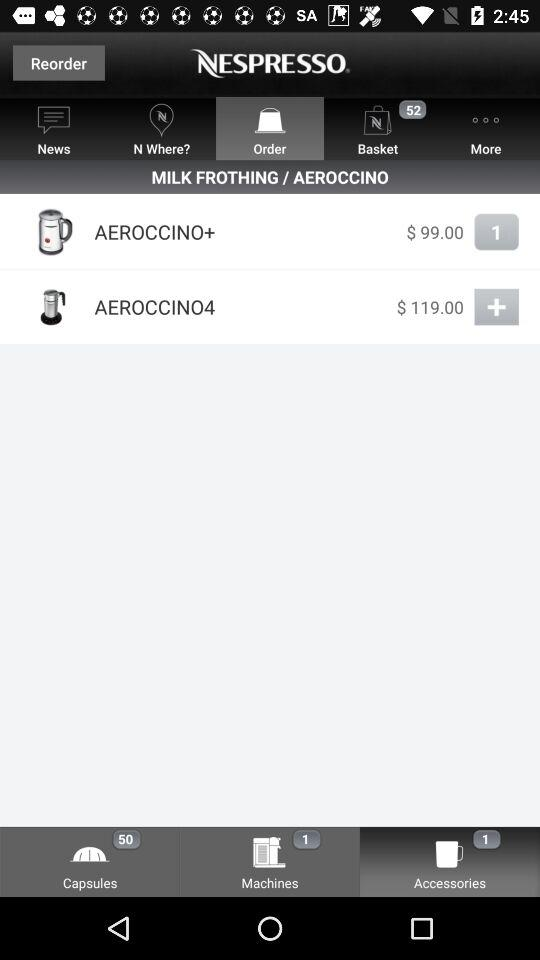Which tab is selected? The selected tabs are "Order" and "Accessories". 